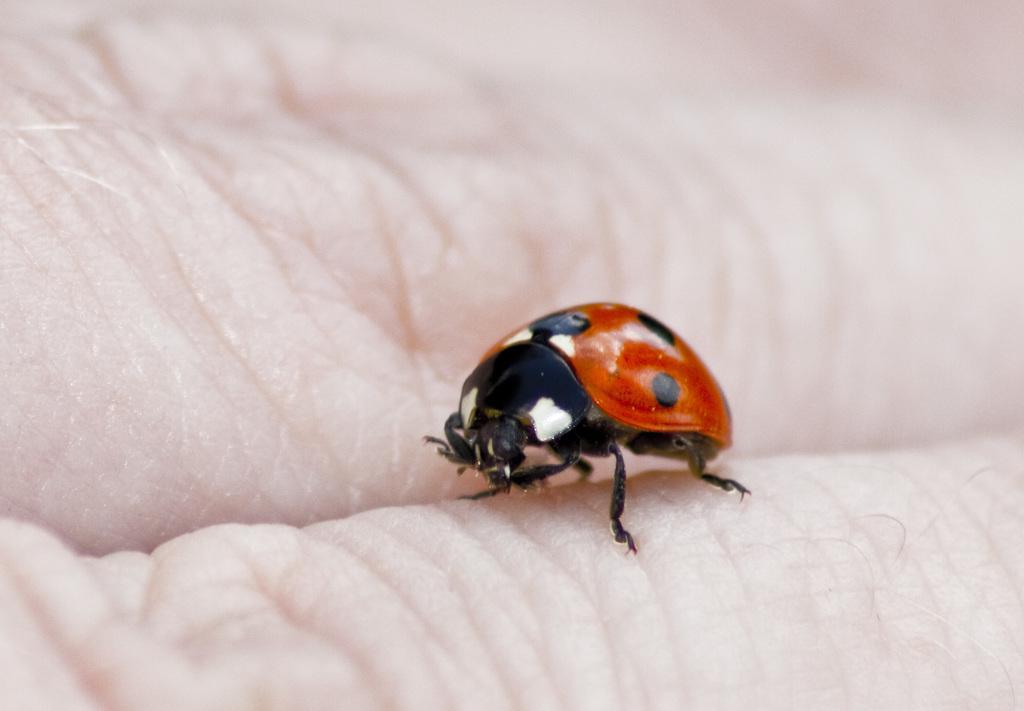Can you describe this image briefly? In this picture I can see the insect. I can see fingers of a person. 